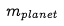Convert formula to latex. <formula><loc_0><loc_0><loc_500><loc_500>m _ { p l a n e t }</formula> 